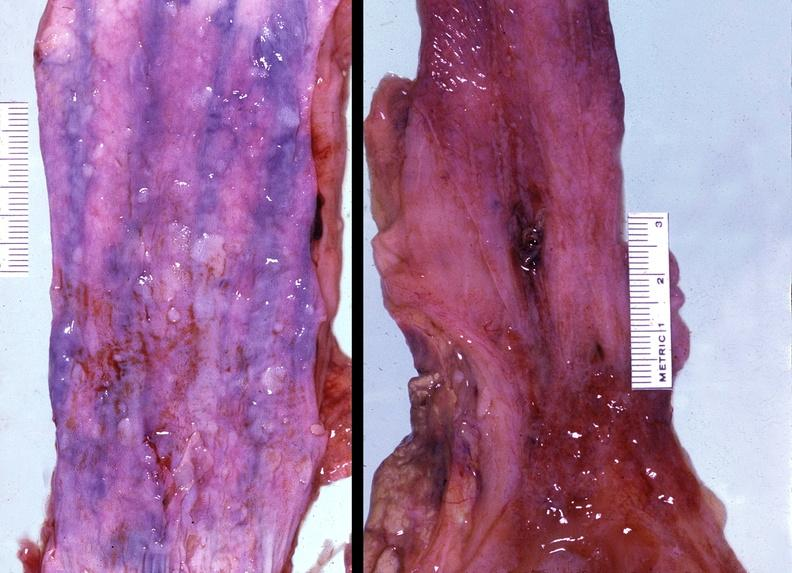s gastrointestinal present?
Answer the question using a single word or phrase. Yes 